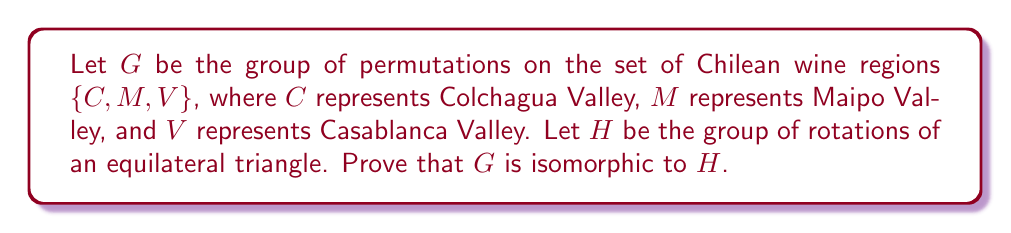Show me your answer to this math problem. To prove that the groups $G$ and $H$ are isomorphic, we need to establish a bijective homomorphism between them. Let's approach this step-by-step:

1. First, let's identify the elements of both groups:

   Group $G$: 
   - $e$ (identity permutation)
   - $(C M)$ (swaps Colchagua and Maipo)
   - $(M V)$ (swaps Maipo and Casablanca)
   - $(C V)$ (swaps Colchagua and Casablanca)
   - $(C M V)$ (cyclic permutation)
   - $(C V M)$ (cyclic permutation)

   Group $H$:
   - $R_0$ (0° rotation, identity)
   - $R_{120}$ (120° clockwise rotation)
   - $R_{240}$ (240° clockwise rotation)

2. Define a mapping $\phi: G \to H$ as follows:
   $$\phi(e) = R_0$$
   $$\phi((C M V)) = R_{120}$$
   $$\phi((C V M)) = R_{240}$$

3. To prove this is an isomorphism, we need to show:
   a) $\phi$ is bijective (one-to-one and onto)
   b) $\phi$ preserves the group operation (homomorphism)

4. Bijectivity:
   - $\phi$ is injective: Each element of $G$ maps to a unique element of $H$.
   - $\phi$ is surjective: Every element of $H$ is mapped to by an element of $G$.

5. Homomorphism:
   We need to show that for any $a, b \in G$, $\phi(ab) = \phi(a)\phi(b)$.
   
   For example:
   $$\phi((C M V)(C M V)) = \phi((C V M)) = R_{240}$$
   $$\phi((C M V))\phi((C M V)) = R_{120}R_{120} = R_{240}$$

   This holds for all combinations of elements in $G$.

6. Order preservation:
   Both groups have order 3, which is preserved by the isomorphism.

Therefore, $\phi$ is an isomorphism between $G$ and $H$.
Answer: The groups $G$ and $H$ are isomorphic. An isomorphism $\phi: G \to H$ is given by:
$$\phi(e) = R_0$$
$$\phi((C M V)) = R_{120}$$
$$\phi((C V M)) = R_{240}$$
This mapping is bijective and preserves the group operation, thus establishing the isomorphism between the permutation group of Chilean wine regions and the rotation group of an equilateral triangle. 